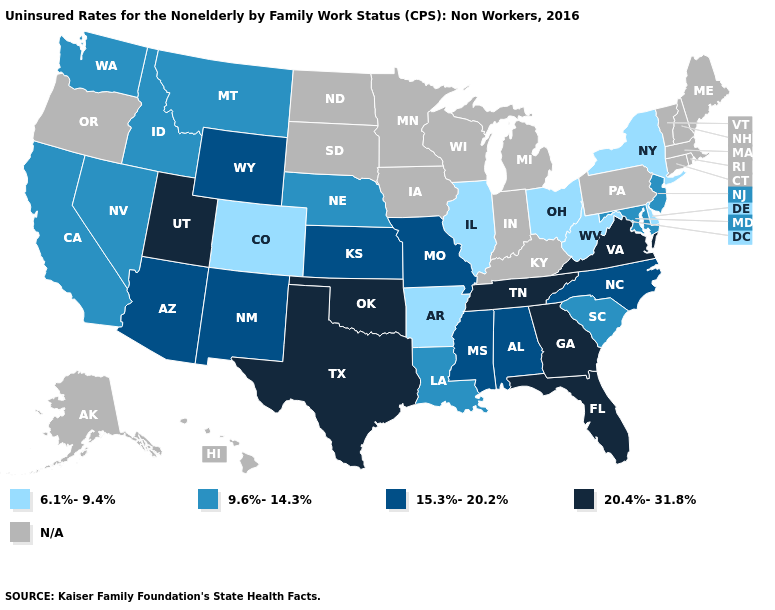Does the first symbol in the legend represent the smallest category?
Write a very short answer. Yes. What is the value of Arkansas?
Write a very short answer. 6.1%-9.4%. How many symbols are there in the legend?
Concise answer only. 5. Name the states that have a value in the range 6.1%-9.4%?
Short answer required. Arkansas, Colorado, Delaware, Illinois, New York, Ohio, West Virginia. Which states have the lowest value in the Northeast?
Quick response, please. New York. What is the highest value in the USA?
Give a very brief answer. 20.4%-31.8%. What is the highest value in states that border Georgia?
Give a very brief answer. 20.4%-31.8%. Does Louisiana have the lowest value in the USA?
Concise answer only. No. What is the value of Texas?
Keep it brief. 20.4%-31.8%. Which states have the highest value in the USA?
Be succinct. Florida, Georgia, Oklahoma, Tennessee, Texas, Utah, Virginia. What is the value of California?
Concise answer only. 9.6%-14.3%. Which states have the lowest value in the West?
Keep it brief. Colorado. Does Texas have the highest value in the USA?
Give a very brief answer. Yes. What is the highest value in states that border Texas?
Give a very brief answer. 20.4%-31.8%. Name the states that have a value in the range 15.3%-20.2%?
Keep it brief. Alabama, Arizona, Kansas, Mississippi, Missouri, New Mexico, North Carolina, Wyoming. 